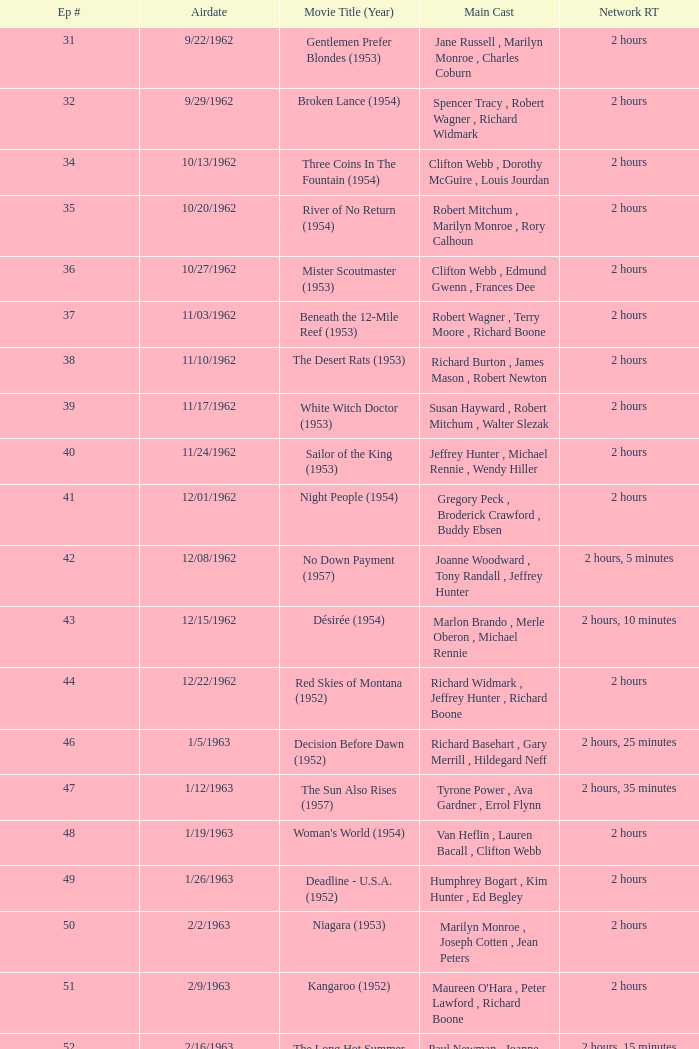What movie did dana wynter , mel ferrer , theodore bikel star in? Fraulein (1958). 